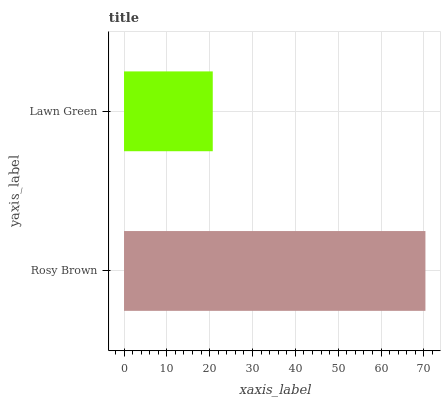Is Lawn Green the minimum?
Answer yes or no. Yes. Is Rosy Brown the maximum?
Answer yes or no. Yes. Is Lawn Green the maximum?
Answer yes or no. No. Is Rosy Brown greater than Lawn Green?
Answer yes or no. Yes. Is Lawn Green less than Rosy Brown?
Answer yes or no. Yes. Is Lawn Green greater than Rosy Brown?
Answer yes or no. No. Is Rosy Brown less than Lawn Green?
Answer yes or no. No. Is Rosy Brown the high median?
Answer yes or no. Yes. Is Lawn Green the low median?
Answer yes or no. Yes. Is Lawn Green the high median?
Answer yes or no. No. Is Rosy Brown the low median?
Answer yes or no. No. 